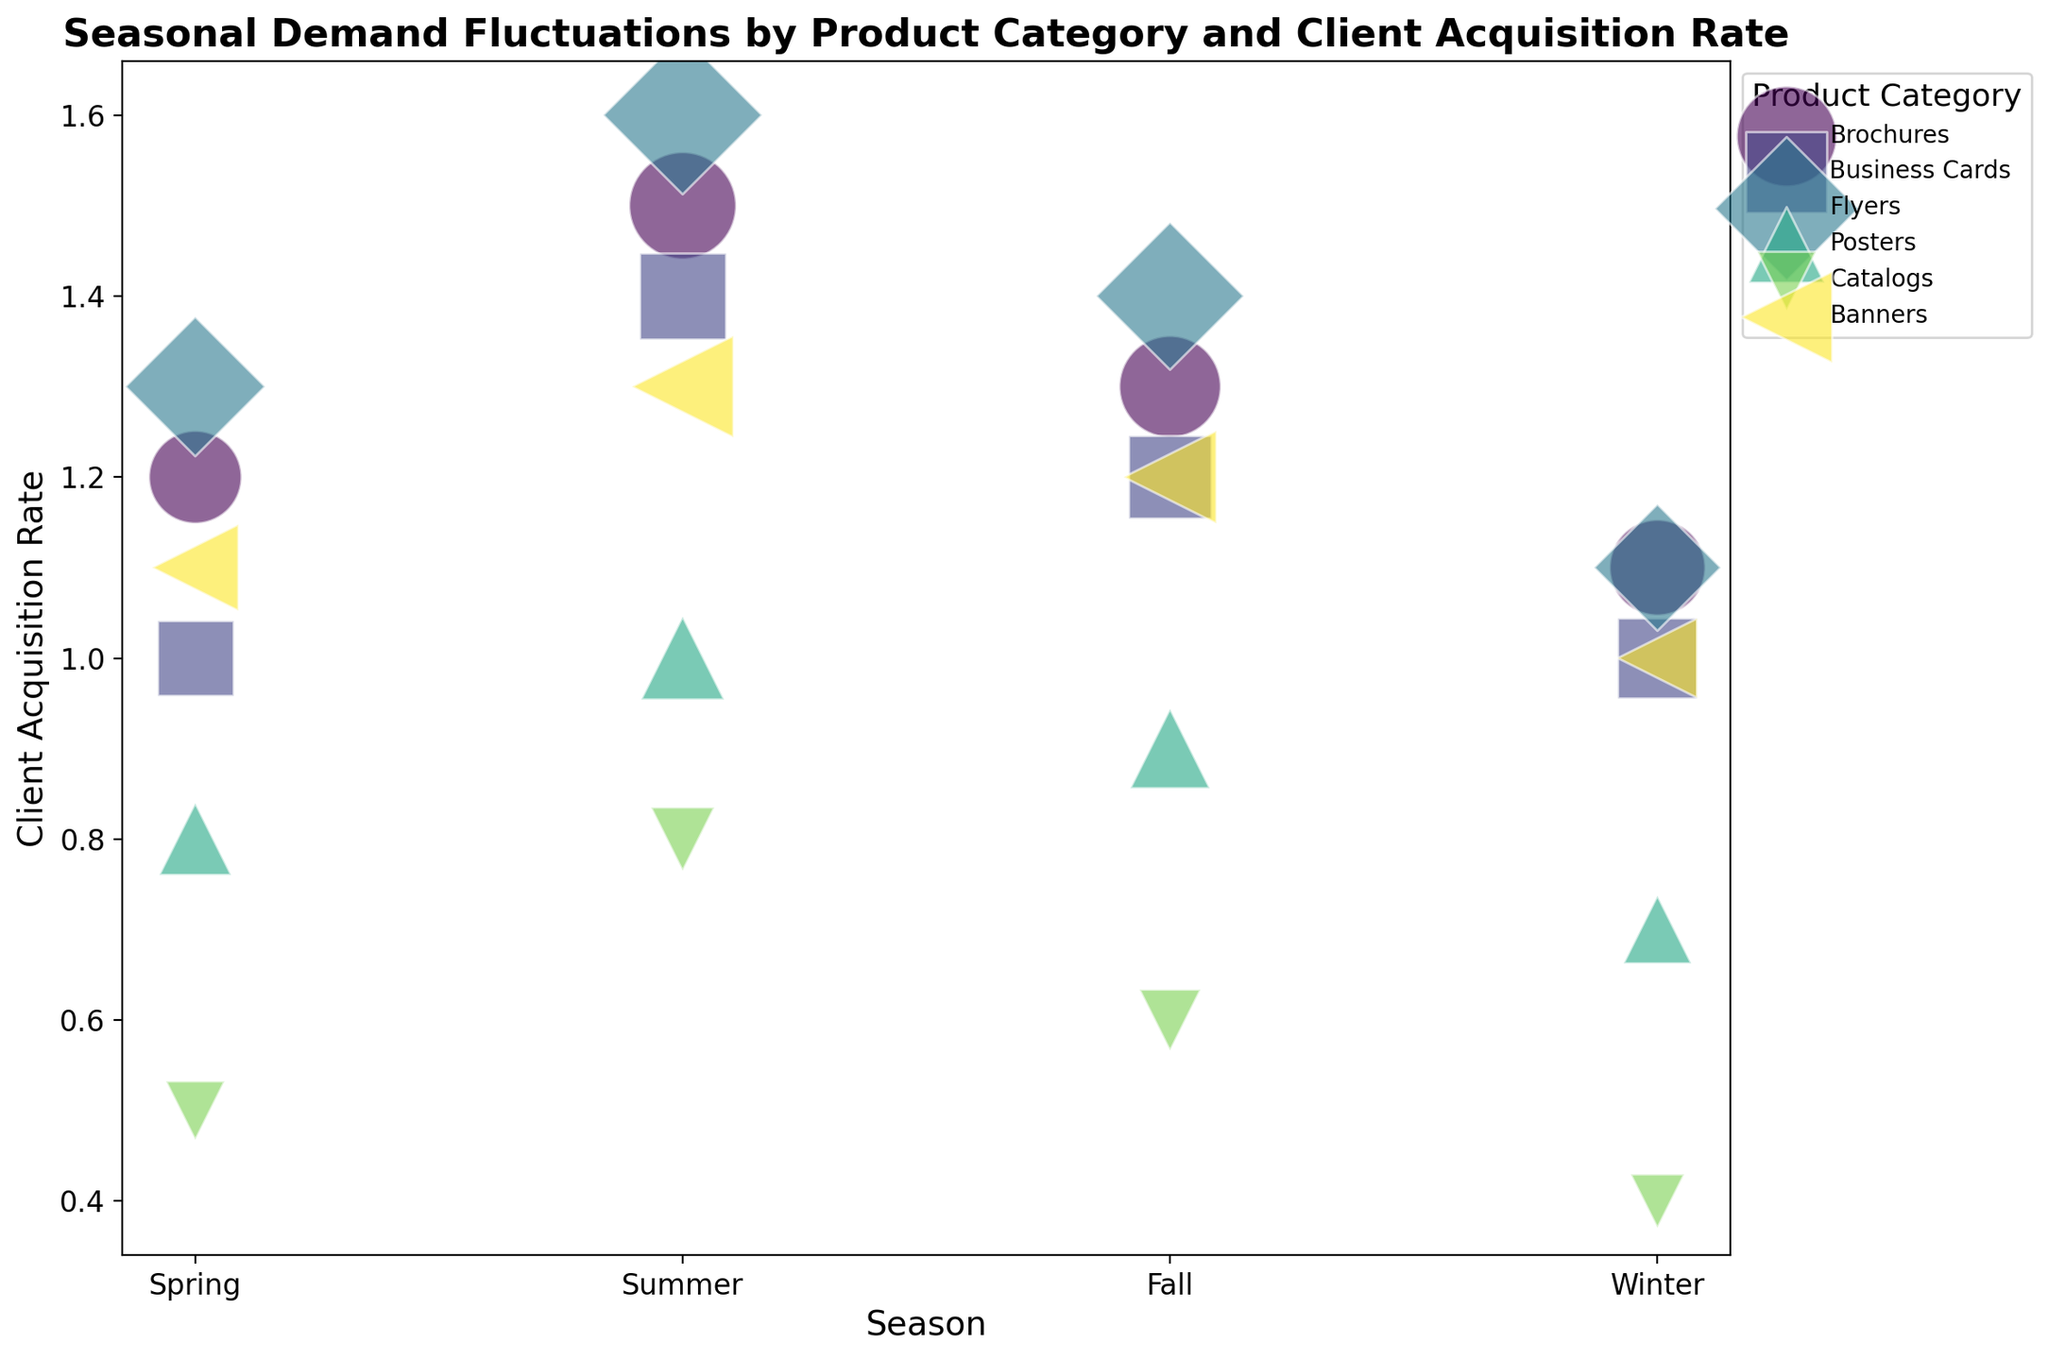What is the product category with the highest average monthly demand during summer? Summer demand for each category is visually represented by the size of the bubbles. The largest bubble in the summer season is for "Flyers," indicating it has the highest average monthly demand during this period.
Answer: Flyers Which season shows the highest client acquisition rate for brochures? By comparing the positions of the bubbles for brochures across all seasons along the y-axis (client acquisition rate), it is evident that "summer" has the highest position, indicating the highest client acquisition rate.
Answer: Summer How does the client acquisition rate for posters in fall compare to that in winter? The client acquisition rate for posters in fall (around 0.9) is higher than in winter (around 0.7), as observed by their positions along the y-axis.
Answer: Fall is higher Which season has the lowest average monthly demand for catalogs? The catalog with the smallest bubble size (indicating the lowest average monthly demand) appears in "winter."
Answer: Winter Is the client acquisition rate for business cards ever higher than for banners in any season? By comparing the y-axis values for business cards and banners across all seasons, it is noted that banners have higher client acquisition rates in all seasons.
Answer: No Which product category has a notable increase in client acquisition rate from spring to summer? "Flyers" observe the most significant vertical shift upwards from spring (around 1.3) to summer (around 1.6), indicating a notable increase in the client acquisition rate.
Answer: Flyers What is the sum of the average monthly demand for banners in spring and fall? The average monthly demand for banners in spring is 130 and in fall is 150. Summing these values gives 130 + 150 = 280.
Answer: 280 Which season shows the least fluctuation in average monthly demand for different product categories? Summer seems to have the most evenly-sized bubbles, indicating the least fluctuation in average monthly demand across different product categories.
Answer: Summer Are there any product categories with a client acquisition rate of 1.0 in any season? By visually inspecting the chart, "Business Cards" in spring and winter, and "Banners" in winter, all have a client acquisition rate of 1.0, as indicated by their position at the 1.0 mark on the y-axis.
Answer: Yes Comparing the average monthly demand for brochures and banners in winter, which has a higher value? By comparing the sizes of the bubbles for brochures and banners in the winter season, the bubble for brochures is larger than that for banners, indicating a higher average monthly demand.
Answer: Brochures 